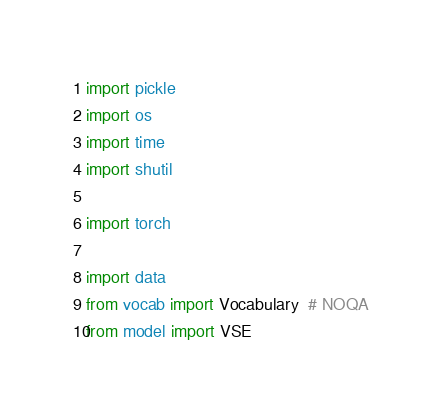Convert code to text. <code><loc_0><loc_0><loc_500><loc_500><_Python_>import pickle
import os
import time
import shutil

import torch

import data
from vocab import Vocabulary  # NOQA
from model import VSE</code> 